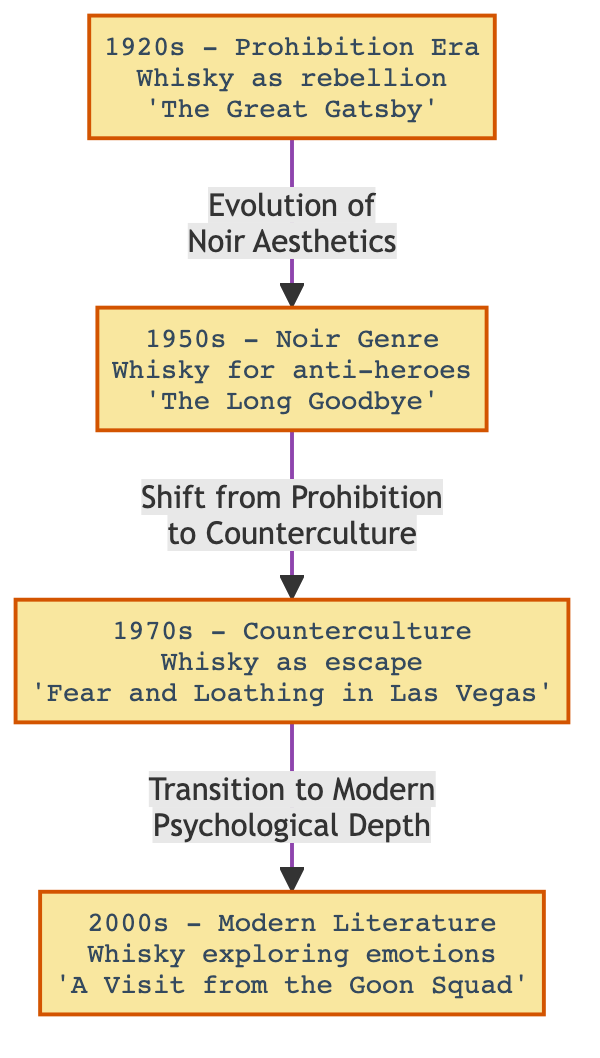What era is represented by the node with whisky as rebellion? The node specifically mentions the 1920s and associates whisky with rebellion, depicting the cultural context of Prohibition during that decade.
Answer: 1920s Which literary work is cited in the 1950s node? The node for the 1950s includes the title 'The Long Goodbye,' indicating it's a key literary work from that era in relation to whisky mentions.
Answer: The Long Goodbye What is the relationship between the 1970s and 2000s nodes? The diagram shows a transition marked by "Transition to Modern Psychological Depth" from the 1970s to the 2000s, indicating a shift in the thematic representation of whisky in literature.
Answer: Transition to Modern Psychological Depth How many nodes does the diagram contain? The diagram has a total of four nodes, each representing a different decade and context regarding whisky mentions in literature.
Answer: 4 What is the theme associated with whisky in the 1970s? The theme depicted in the 1970s node describes whisky as an escape, reflecting the counterculture movement of that period.
Answer: Whisky as escape What color represents the 2000s node? The color associated with the 2000s node is orange, as indicated by the diagram's color coding for different decades.
Answer: Orange What is the main evolution conveyed from the 1920s to the 1950s? The transition from the 1920s to the 1950s is described as the "Evolution of Noir Aesthetics," suggesting a development in literary styles and themes regarding whisky.
Answer: Evolution of Noir Aesthetics Which decade explores emotional themes associated with whisky? According to the diagram, the 2000s decade is where whisky explores deeper emotional themes in literature, as marked by the relevant node description.
Answer: 2000s What literary trend does the 1950s node reflect? The 1950s node reflects the literary trend of the Noir Genre, illustrating its association with whisky in relation to anti-hero characters.
Answer: Noir Genre 